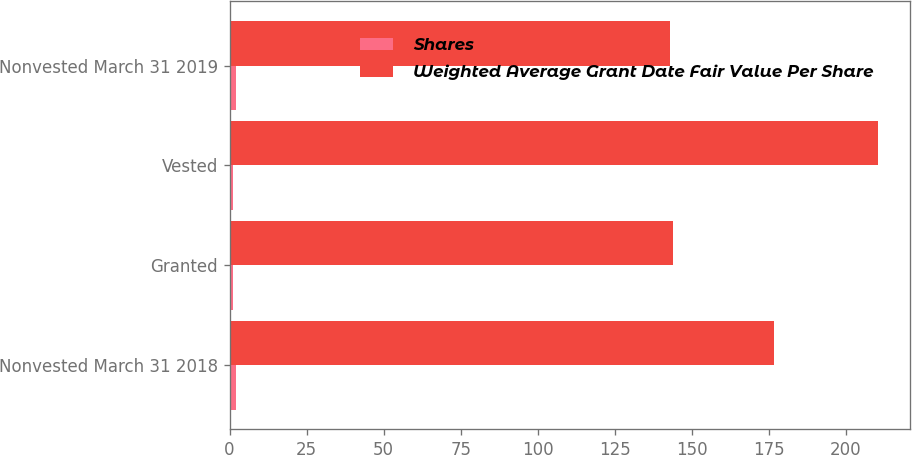Convert chart to OTSL. <chart><loc_0><loc_0><loc_500><loc_500><stacked_bar_chart><ecel><fcel>Nonvested March 31 2018<fcel>Granted<fcel>Vested<fcel>Nonvested March 31 2019<nl><fcel>Shares<fcel>2<fcel>1<fcel>1<fcel>2<nl><fcel>Weighted Average Grant Date Fair Value Per Share<fcel>176.74<fcel>143.94<fcel>210.3<fcel>142.77<nl></chart> 